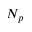<formula> <loc_0><loc_0><loc_500><loc_500>N _ { p }</formula> 